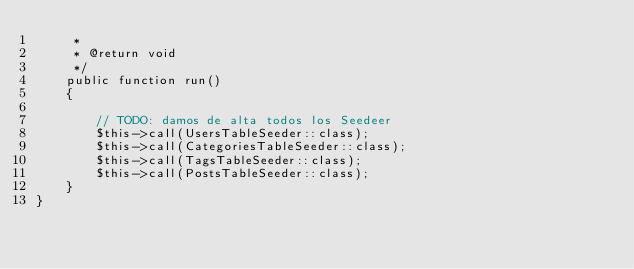Convert code to text. <code><loc_0><loc_0><loc_500><loc_500><_PHP_>     *
     * @return void
     */
    public function run()
    {

        // TODO: damos de alta todos los Seedeer
        $this->call(UsersTableSeeder::class);
        $this->call(CategoriesTableSeeder::class);
        $this->call(TagsTableSeeder::class);
        $this->call(PostsTableSeeder::class);
    }
}
</code> 